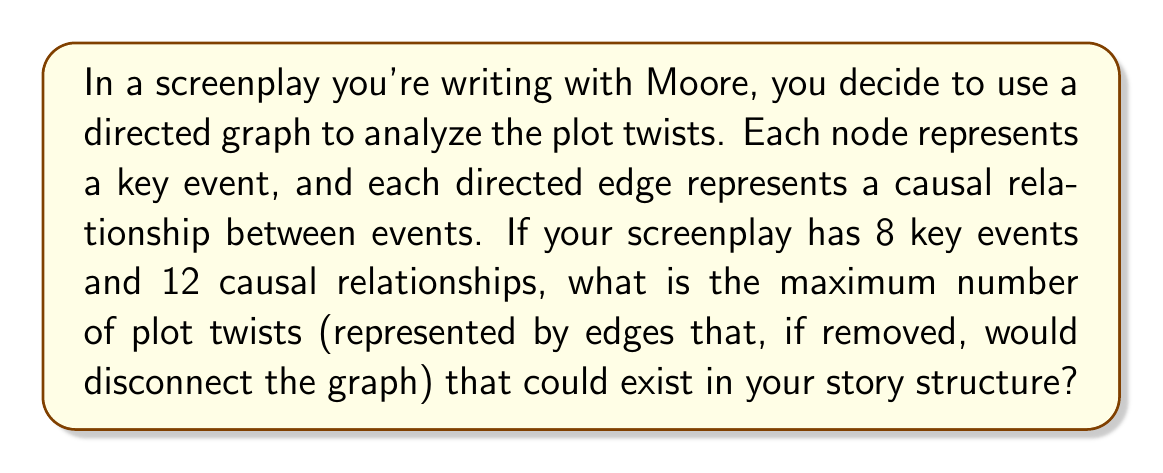Could you help me with this problem? To solve this problem, we need to consider the concept of bridges in graph theory. In a directed graph:

1) A plot twist can be represented by a bridge - an edge whose removal would disconnect the graph.

2) The maximum number of bridges occurs in a graph with a tree structure, where every edge is a bridge.

3) In a tree with $n$ nodes, there are exactly $n-1$ edges.

4) Given:
   - Number of nodes (key events) = 8
   - Number of edges (causal relationships) = 12

5) To maximize the number of plot twists (bridges), we need to create a tree structure with 8 nodes, which would have 7 edges.

6) The remaining 5 edges (12 - 7 = 5) can be added in a way that doesn't create any cycles, ensuring they're all bridges.

7) Therefore, the maximum number of plot twists (bridges) is:
   $$(n-1) + (e-(n-1)) = e = 12$$

Where $n$ is the number of nodes and $e$ is the number of edges.

This structure would create a directed acyclic graph (DAG) where every edge is critical to the connectivity of the graph, representing a story where each causal relationship is crucial to the plot progression.
Answer: 12 